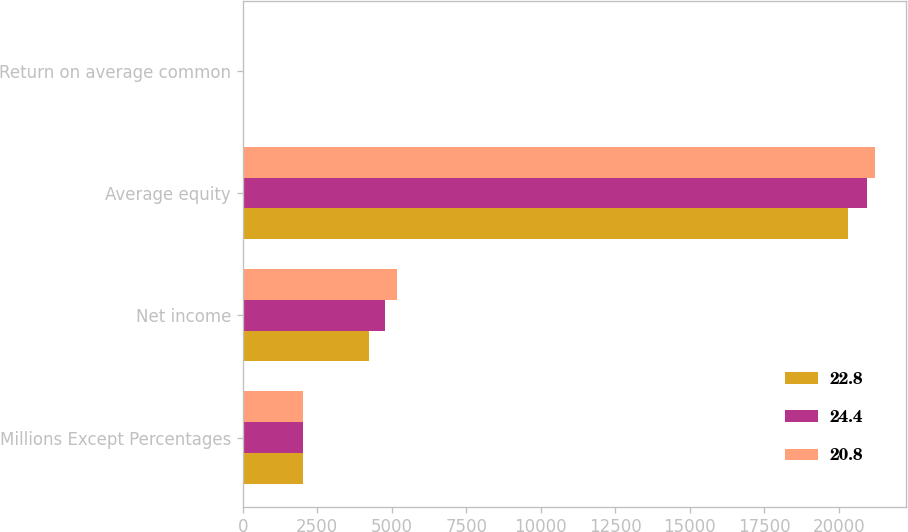<chart> <loc_0><loc_0><loc_500><loc_500><stacked_bar_chart><ecel><fcel>Millions Except Percentages<fcel>Net income<fcel>Average equity<fcel>Return on average common<nl><fcel>22.8<fcel>2016<fcel>4233<fcel>20317<fcel>20.8<nl><fcel>24.4<fcel>2015<fcel>4772<fcel>20946<fcel>22.8<nl><fcel>20.8<fcel>2014<fcel>5180<fcel>21207<fcel>24.4<nl></chart> 